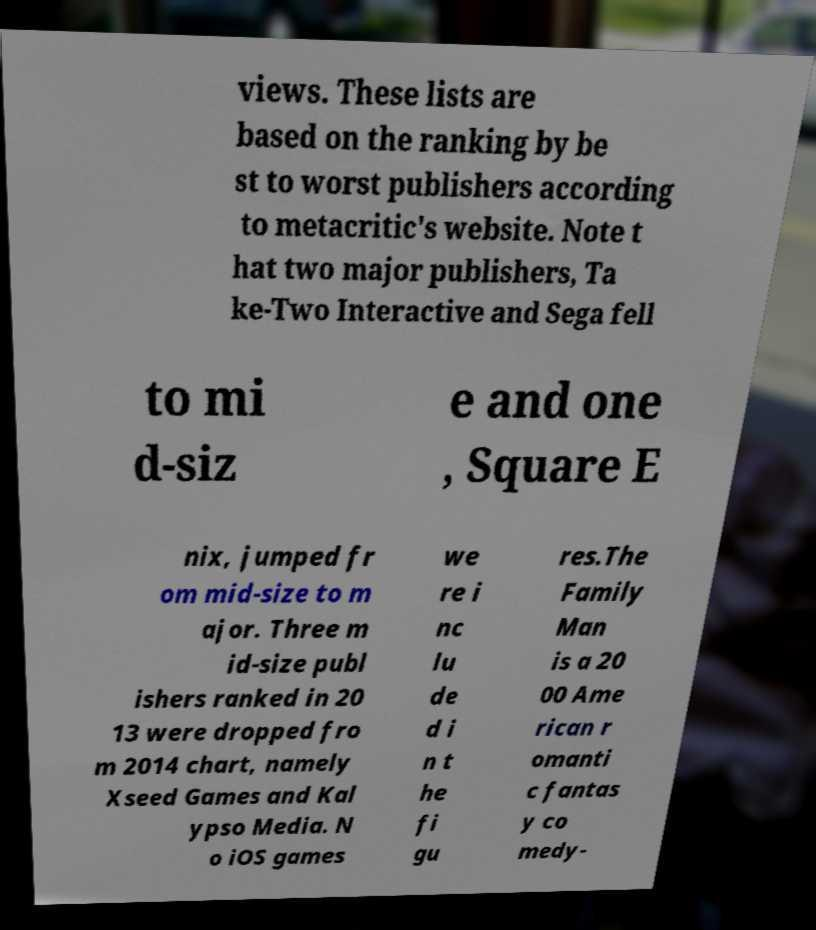There's text embedded in this image that I need extracted. Can you transcribe it verbatim? views. These lists are based on the ranking by be st to worst publishers according to metacritic's website. Note t hat two major publishers, Ta ke-Two Interactive and Sega fell to mi d-siz e and one , Square E nix, jumped fr om mid-size to m ajor. Three m id-size publ ishers ranked in 20 13 were dropped fro m 2014 chart, namely Xseed Games and Kal ypso Media. N o iOS games we re i nc lu de d i n t he fi gu res.The Family Man is a 20 00 Ame rican r omanti c fantas y co medy- 